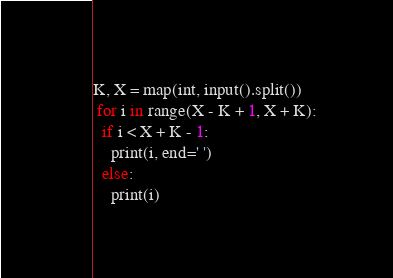<code> <loc_0><loc_0><loc_500><loc_500><_Python_>K, X = map(int, input().split())
 for i in range(X - K + 1, X + K):
  if i < X + K - 1:
    print(i, end=' ')
  else:
    print(i)
</code> 